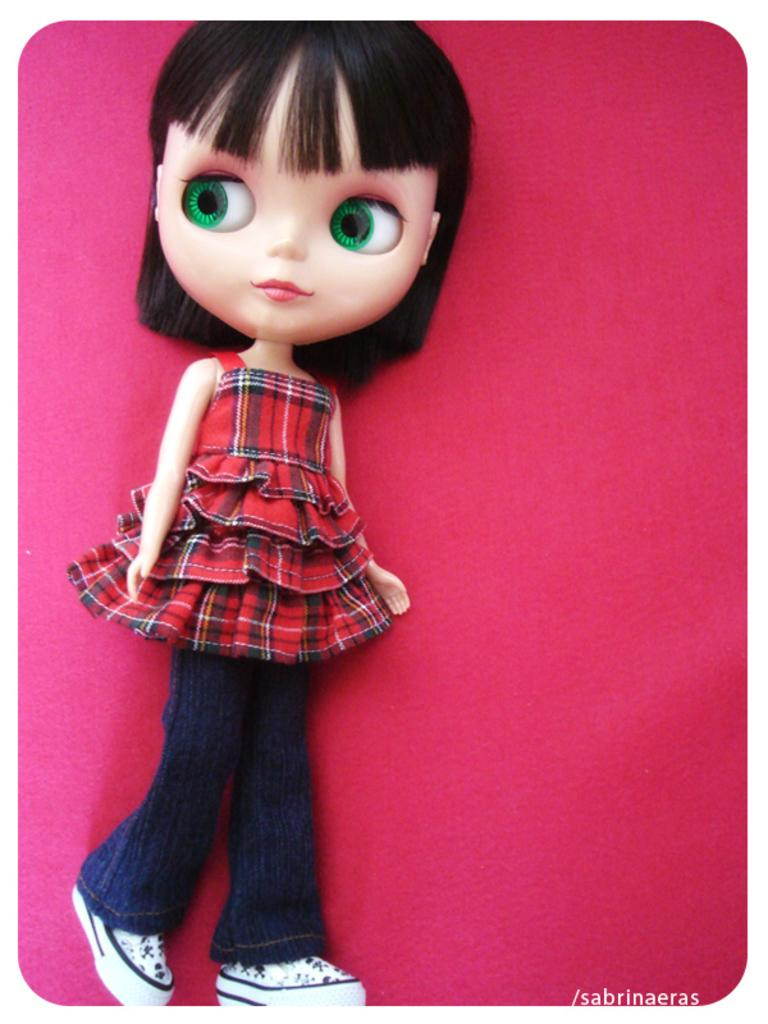What is the main subject of the image? There is a doll in the image. What is the doll wearing on its upper body? The doll is wearing a red top. What is the doll wearing on its lower body? The doll is wearing blue jeans. What type of footwear is the doll wearing? The doll is wearing white shoes. What color is the background of the image? The background of the image is pink. Can you tell me how many goats are in the image? There are no goats present in the image; it features a doll. What type of beam is holding up the ceiling in the image? There is no ceiling or beam visible in the image; it only shows a doll and the background. 